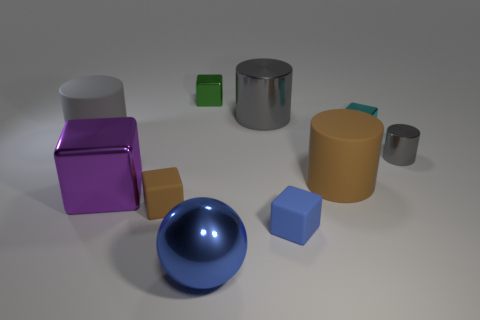Subtract all brown blocks. How many gray cylinders are left? 3 Subtract 2 cubes. How many cubes are left? 3 Subtract all balls. How many objects are left? 9 Add 7 cyan metallic blocks. How many cyan metallic blocks are left? 8 Add 2 rubber cylinders. How many rubber cylinders exist? 4 Subtract 0 yellow blocks. How many objects are left? 10 Subtract all large green rubber balls. Subtract all small shiny cylinders. How many objects are left? 9 